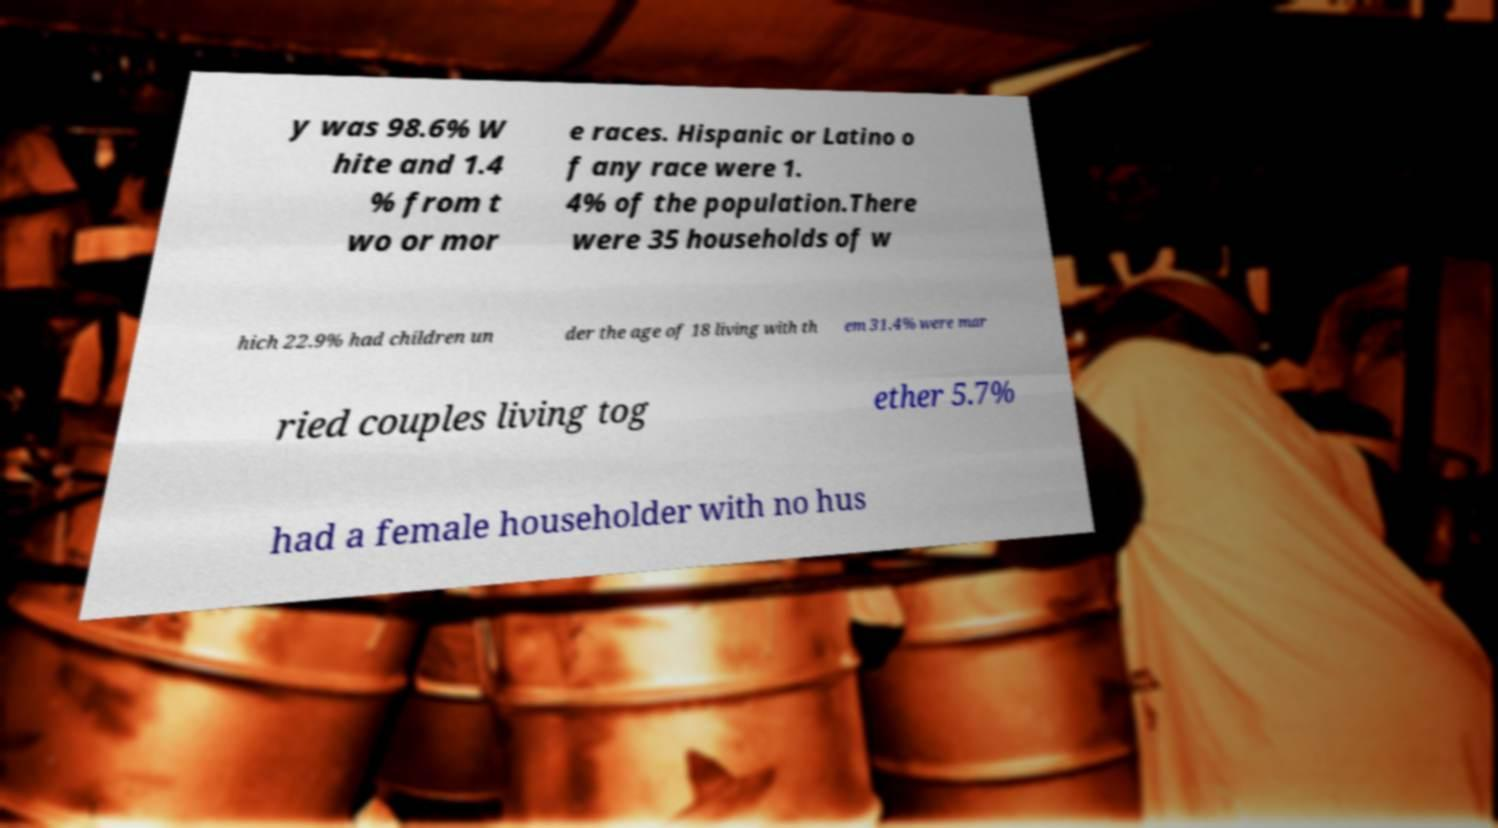Please identify and transcribe the text found in this image. y was 98.6% W hite and 1.4 % from t wo or mor e races. Hispanic or Latino o f any race were 1. 4% of the population.There were 35 households of w hich 22.9% had children un der the age of 18 living with th em 31.4% were mar ried couples living tog ether 5.7% had a female householder with no hus 